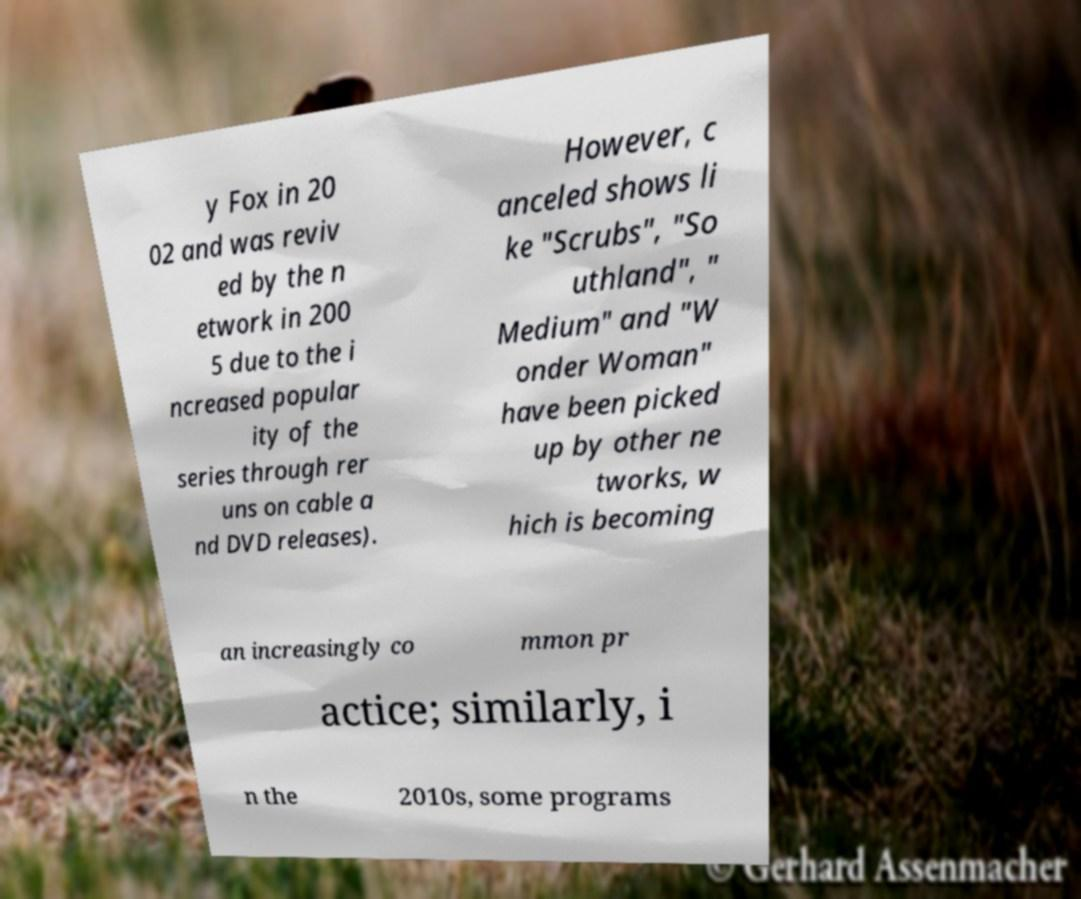For documentation purposes, I need the text within this image transcribed. Could you provide that? y Fox in 20 02 and was reviv ed by the n etwork in 200 5 due to the i ncreased popular ity of the series through rer uns on cable a nd DVD releases). However, c anceled shows li ke "Scrubs", "So uthland", " Medium" and "W onder Woman" have been picked up by other ne tworks, w hich is becoming an increasingly co mmon pr actice; similarly, i n the 2010s, some programs 